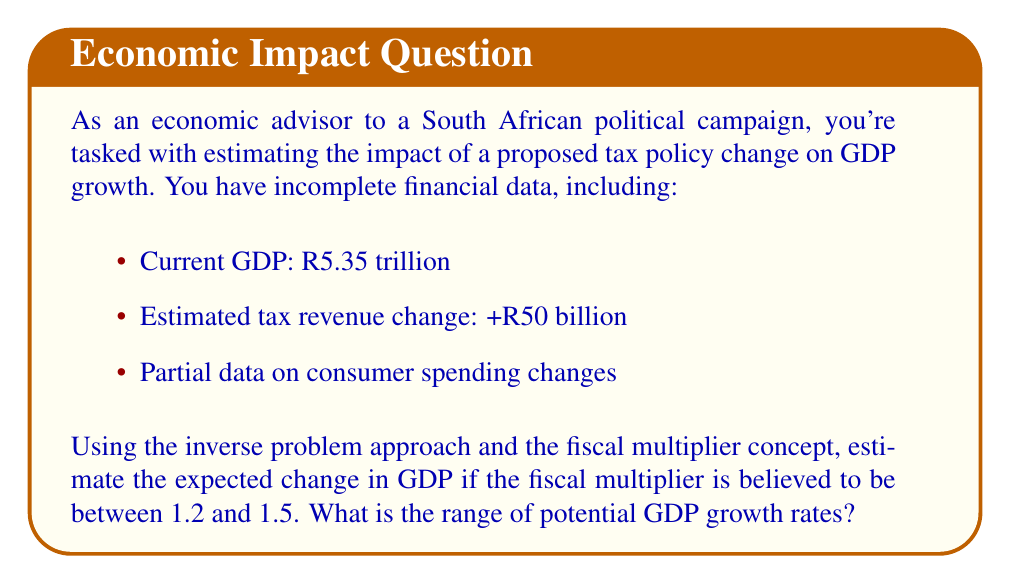What is the answer to this math problem? To solve this inverse problem and determine the economic impact of the policy change, we'll follow these steps:

1. Identify the known variables:
   - Current GDP: R5.35 trillion
   - Estimated tax revenue change: +R50 billion
   - Fiscal multiplier range: 1.2 to 1.5

2. Use the fiscal multiplier concept to calculate the range of GDP change:
   - Lower bound: $\Delta GDP_{min} = 1.2 \times R50\text{ billion} = R60\text{ billion}$
   - Upper bound: $\Delta GDP_{max} = 1.5 \times R50\text{ billion} = R75\text{ billion}$

3. Calculate the new GDP range:
   - Minimum new GDP: $R5.35\text{ trillion} + R60\text{ billion} = R5.41\text{ trillion}$
   - Maximum new GDP: $R5.35\text{ trillion} + R75\text{ billion} = R5.425\text{ trillion}$

4. Calculate the GDP growth rate range:
   - Minimum growth rate: $\frac{R5.41\text{ trillion} - R5.35\text{ trillion}}{R5.35\text{ trillion}} \times 100\% = 1.12\%$
   - Maximum growth rate: $\frac{R5.425\text{ trillion} - R5.35\text{ trillion}}{R5.35\text{ trillion}} \times 100\% = 1.40\%$

Therefore, the range of potential GDP growth rates is 1.12% to 1.40%.
Answer: 1.12% to 1.40% 